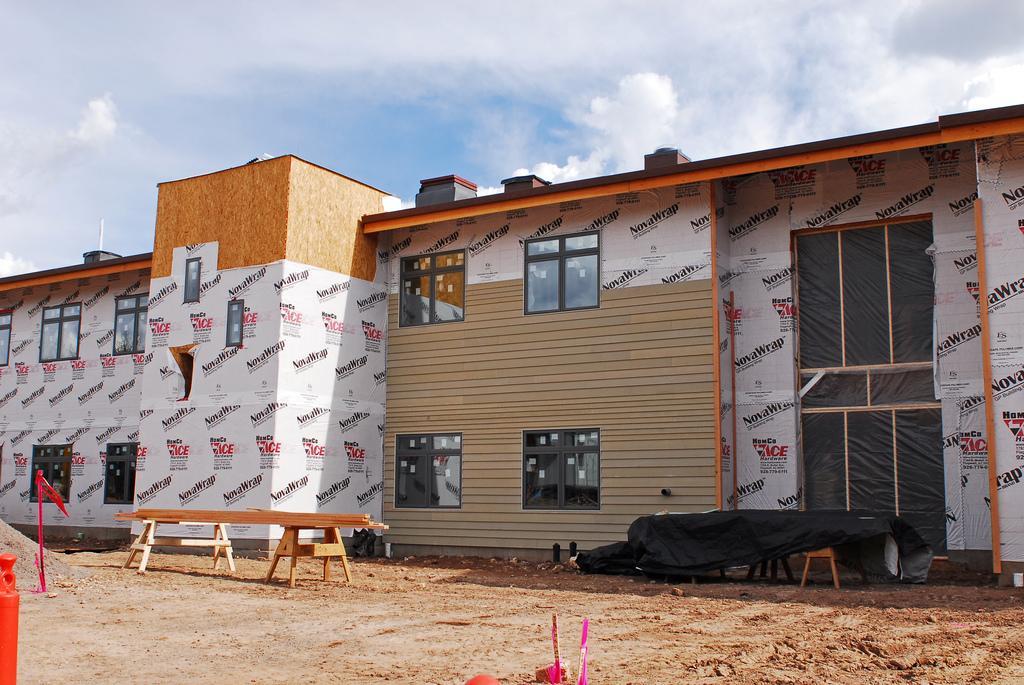Describe this image in one or two sentences. In this picture we can see the building. In front of the building we can see the benches and wooden sticks. At the top can see sky and clouds. On the building we can see the windows. 